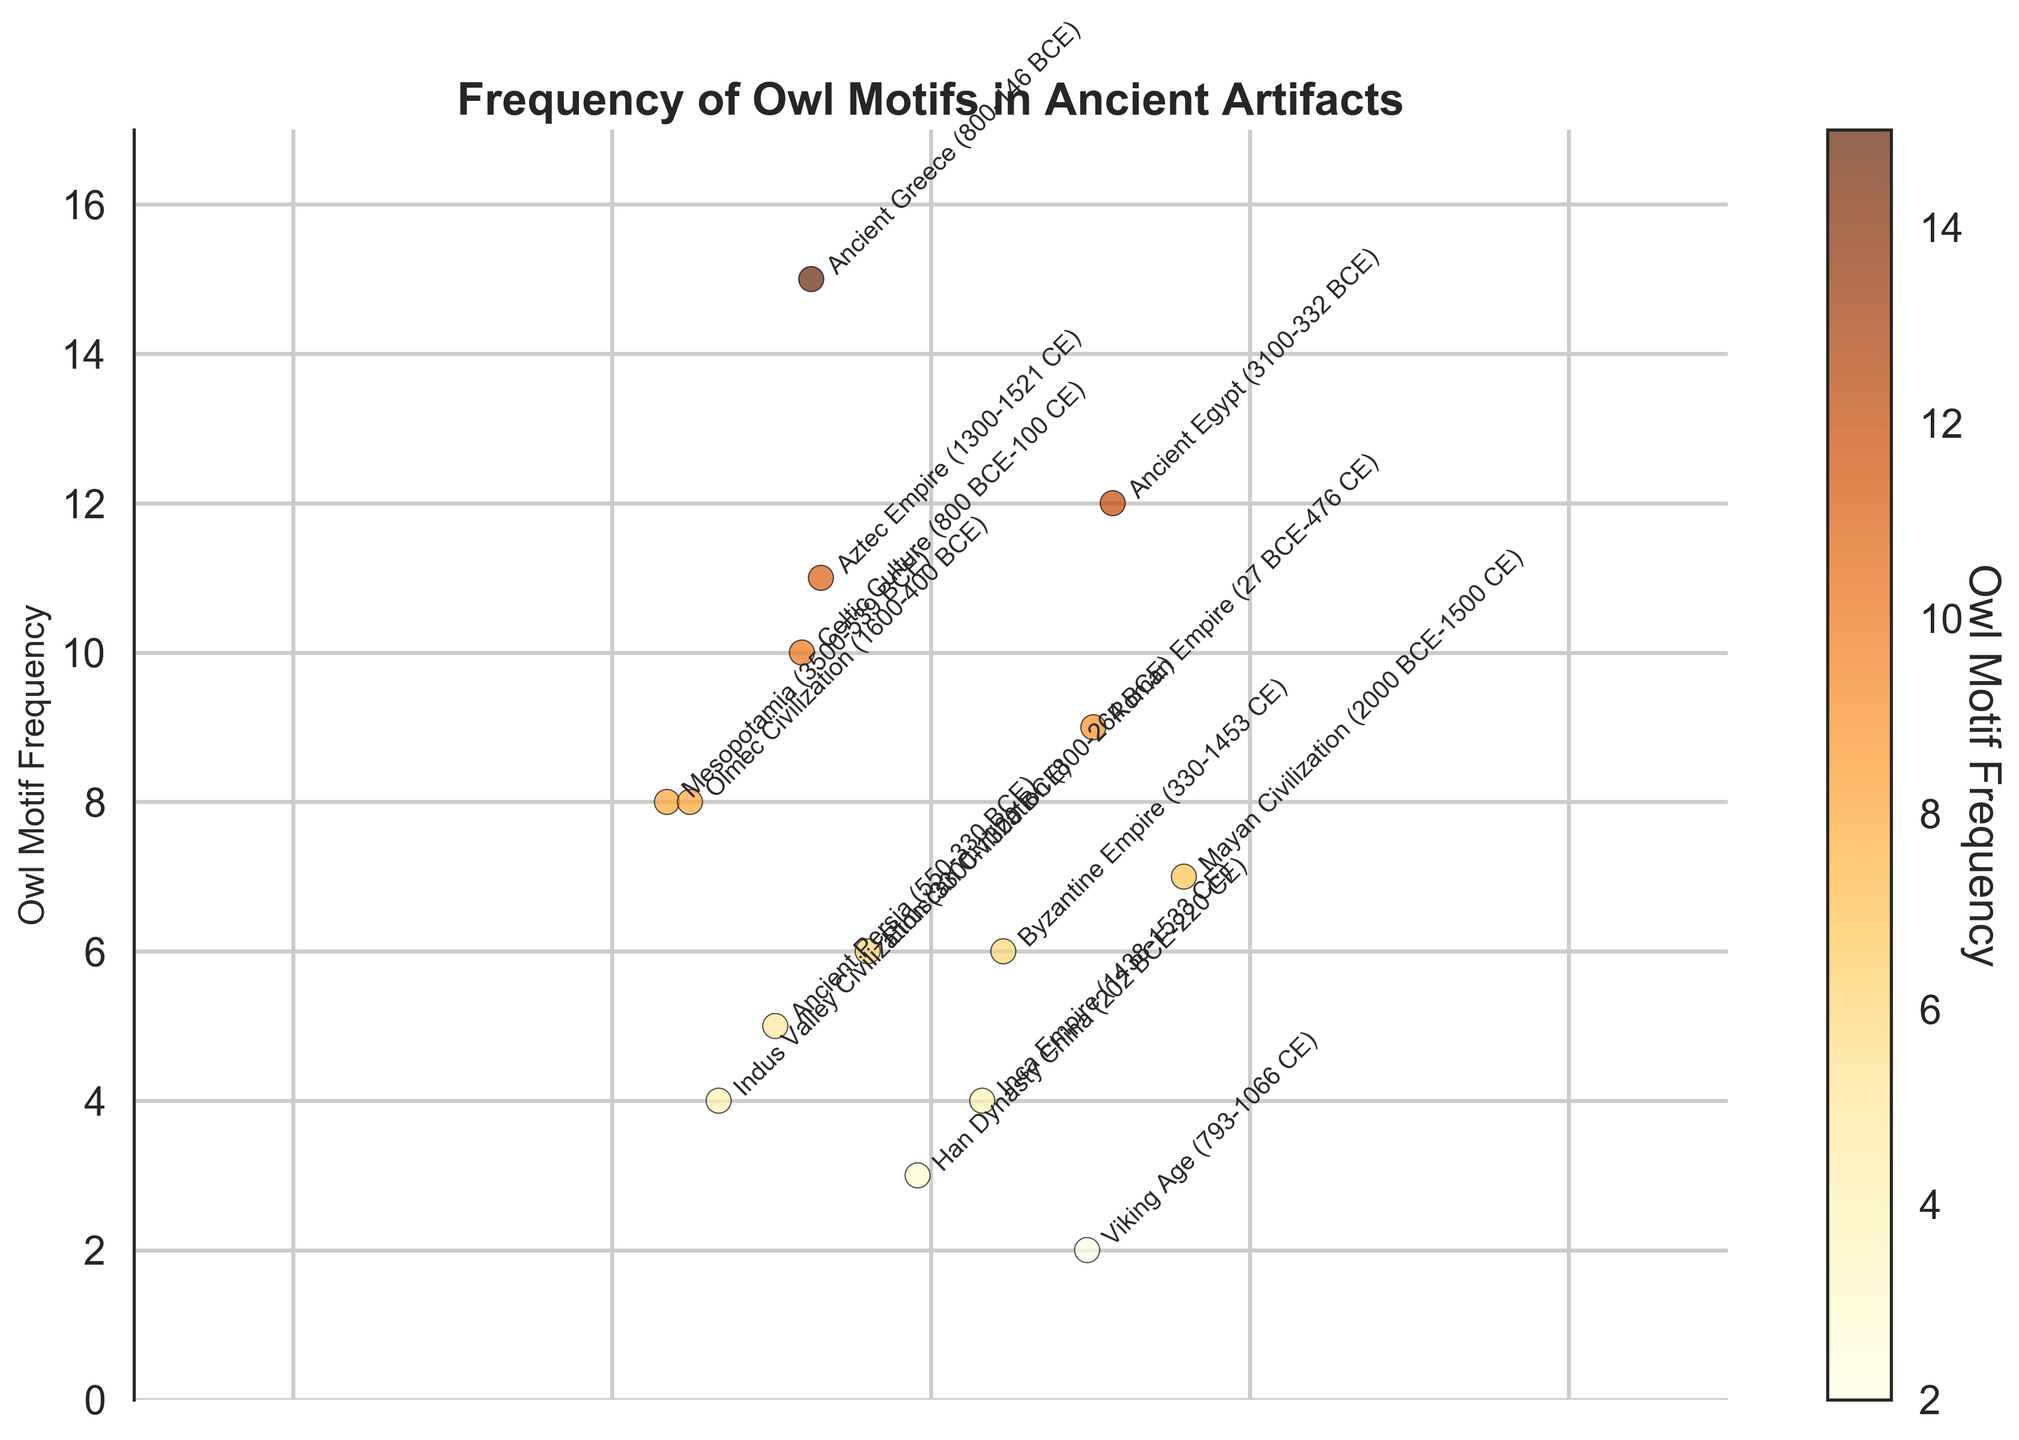What is the title of the figure? The title is usually placed on top of the figure; it reads "Frequency of Owl Motifs in Ancient Artifacts".
Answer: Frequency of Owl Motifs in Ancient Artifacts How many civilizations have their owl motif frequencies displayed in the plot? Each annotated data point stands for one civilization. Counting the annotations gives the number of civilizations, which is 15.
Answer: 15 Which civilization has the highest frequency of owl motifs? By looking at the highest point in the vertical axis, it corresponds to the annotation "Ancient Greece", which has a frequency of 15.
Answer: Ancient Greece What is the range of the owl motif frequencies in the figure? The lowest frequency is at 2 (Viking Age) and the highest at 15 (Ancient Greece), so the range is 15 - 2 = 13.
Answer: 13 How do the owl motif frequencies of the Roman Empire and Byzantine Empire compare? Locate the points and annotations of both the Roman Empire and the Byzantine Empire, then compare their values. The Roman Empire has a frequency of 9 while the Byzantine Empire has a frequency of 6.
Answer: Roman Empire: 9, Byzantine Empire: 6 What is the average frequency of owl motifs across all ancient civilizations in the plot? Sum all frequencies and divide by the number of data points (15). The frequencies are: 12 + 8 + 15 + 6 + 9 + 3 + 7 + 11 + 4 + 5 + 10 + 2 + 6 + 4 + 8. The sum is 110. The average is 110 / 15 = 7.33 (rounded to 2 decimal places).
Answer: 7.33 Which civilization has a frequency closest to the average frequency of all civilizations? Calculate the average frequency as 7.33. Find the civilization with the frequency closest to 7.33 by comparing all values. Mayan Civilization has a frequency of 7, which is the closest to 7.33.
Answer: Mayan Civilization How does the owl motif frequency of the Mayan Civilization compare to that of the Olmec Civilization? Locate the annotations for the Mayan and Olmec Civilizations. The Mayan Civilization has an owl motif frequency of 7, while the Olmec Civilization has a frequency of 8.
Answer: Mayan: 7, Olmec: 8 Which time period shows a lower owl motif frequency, the Etruscan Civilization or the Viking Age? Locate the data points and annotations for the Etruscan Civilization and the Viking Age. The Etruscan Civilization has a frequency of 6, and the Viking Age has a frequency of 2.
Answer: Viking Age (2) What is the difference in owl motif frequency between Ancient Egypt and Han Dynasty China? Determine the owl motif frequencies for Ancient Egypt and Han Dynasty China. Ancient Egypt has a frequency of 12, while Han Dynasty China has a frequency of 3. The difference is 12 - 3 = 9.
Answer: 9 